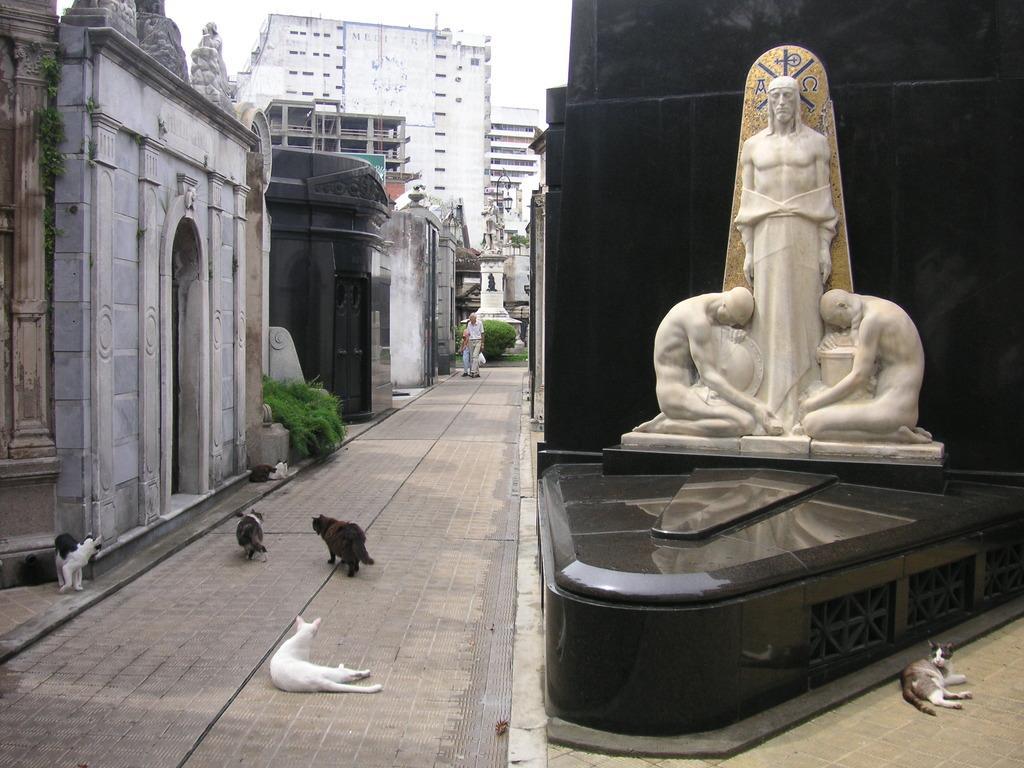How would you summarize this image in a sentence or two? There is a statue and a cat present on the right side of this image. There are cats at the bottom of this image. We can see the buildings in the background. There is one person standing in the middle of this image. 